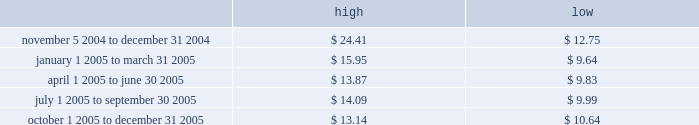Part ii price range our common stock commenced trading on the nasdaq national market under the symbol 201cmktx 201d on november 5 , 2004 .
Prior to that date , there was no public market for our common stock .
The high and low bid information for our common stock , as reported by nasdaq , was as follows : on march 8 , 2006 , the last reported closing price of our common stock on the nasdaq national market was $ 12.59 .
Holders there were approximately 114 holders of record of our common stock as of march 8 , 2006 .
Dividend policy we have not declared or paid any cash dividends on our capital stock since our inception .
We intend to retain future earnings to finance the operation and expansion of our business and do not anticipate paying any cash dividends in the foreseeable future .
In the event we decide to declare dividends on our common stock in the future , such declaration will be subject to the discretion of our board of directors .
Our board may take into account such matters as general business conditions , our financial results , capital requirements , contractual , legal , and regulatory restrictions on the payment of dividends by us to our stockholders or by our subsidiaries to us and any such other factors as our board may deem relevant .
Use of proceeds on november 4 , 2004 , the registration statement relating to our initial public offering ( no .
333-112718 ) was declared effective .
We received net proceeds from the sale of the shares of our common stock in the offering of $ 53.9 million , at an initial public offering price of $ 11.00 per share , after deducting underwriting discounts and commissions and estimated offering expenses .
Except for salaries , and reimbursements for travel expenses and other out-of -pocket costs incurred in the ordinary course of business , none of the proceeds from the offering have been paid by us , directly or indirectly , to any of our directors or officers or any of their associates , or to any persons owning ten percent or more of our outstanding stock or to any of our affiliates .
We have invested the proceeds from the offering in cash and cash equivalents and short-term marketable securities .
Item 5 .
Market for registrant 2019s common equity , related stockholder matters and issuer purchases of equity securities .

For the period july 1 2005 to september 30 2005 , what was the lowest share price>? 
Computations: table_min(july 1 2005 to september 30 2005, none)
Answer: 9.99. 